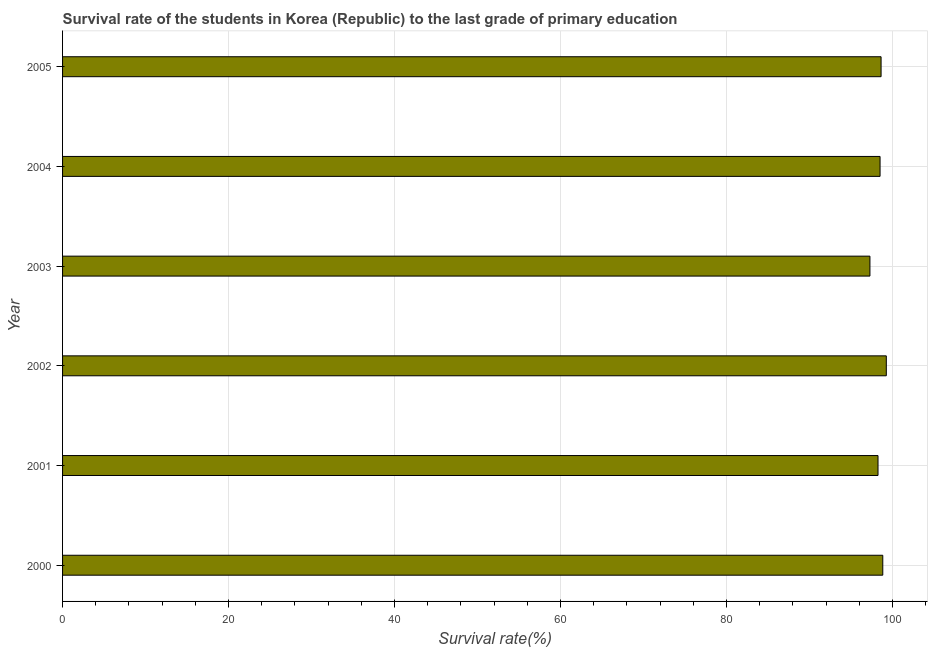What is the title of the graph?
Provide a succinct answer. Survival rate of the students in Korea (Republic) to the last grade of primary education. What is the label or title of the X-axis?
Ensure brevity in your answer.  Survival rate(%). What is the survival rate in primary education in 2002?
Ensure brevity in your answer.  99.24. Across all years, what is the maximum survival rate in primary education?
Make the answer very short. 99.24. Across all years, what is the minimum survival rate in primary education?
Provide a succinct answer. 97.27. What is the sum of the survival rate in primary education?
Provide a short and direct response. 590.69. What is the difference between the survival rate in primary education in 2000 and 2001?
Provide a short and direct response. 0.57. What is the average survival rate in primary education per year?
Provide a short and direct response. 98.45. What is the median survival rate in primary education?
Keep it short and to the point. 98.55. Do a majority of the years between 2004 and 2005 (inclusive) have survival rate in primary education greater than 48 %?
Keep it short and to the point. Yes. Is the difference between the survival rate in primary education in 2002 and 2003 greater than the difference between any two years?
Ensure brevity in your answer.  Yes. What is the difference between the highest and the second highest survival rate in primary education?
Your answer should be very brief. 0.42. Is the sum of the survival rate in primary education in 2000 and 2004 greater than the maximum survival rate in primary education across all years?
Provide a succinct answer. Yes. What is the difference between the highest and the lowest survival rate in primary education?
Keep it short and to the point. 1.97. Are all the bars in the graph horizontal?
Your answer should be compact. Yes. How many years are there in the graph?
Your answer should be compact. 6. Are the values on the major ticks of X-axis written in scientific E-notation?
Your response must be concise. No. What is the Survival rate(%) in 2000?
Ensure brevity in your answer.  98.82. What is the Survival rate(%) in 2001?
Offer a very short reply. 98.25. What is the Survival rate(%) in 2002?
Provide a succinct answer. 99.24. What is the Survival rate(%) of 2003?
Ensure brevity in your answer.  97.27. What is the Survival rate(%) of 2004?
Your response must be concise. 98.49. What is the Survival rate(%) in 2005?
Make the answer very short. 98.62. What is the difference between the Survival rate(%) in 2000 and 2001?
Offer a terse response. 0.57. What is the difference between the Survival rate(%) in 2000 and 2002?
Make the answer very short. -0.43. What is the difference between the Survival rate(%) in 2000 and 2003?
Your answer should be compact. 1.55. What is the difference between the Survival rate(%) in 2000 and 2004?
Your answer should be compact. 0.33. What is the difference between the Survival rate(%) in 2000 and 2005?
Ensure brevity in your answer.  0.2. What is the difference between the Survival rate(%) in 2001 and 2002?
Offer a very short reply. -1. What is the difference between the Survival rate(%) in 2001 and 2003?
Give a very brief answer. 0.97. What is the difference between the Survival rate(%) in 2001 and 2004?
Provide a short and direct response. -0.25. What is the difference between the Survival rate(%) in 2001 and 2005?
Your answer should be very brief. -0.37. What is the difference between the Survival rate(%) in 2002 and 2003?
Your response must be concise. 1.97. What is the difference between the Survival rate(%) in 2002 and 2004?
Provide a succinct answer. 0.75. What is the difference between the Survival rate(%) in 2002 and 2005?
Your response must be concise. 0.63. What is the difference between the Survival rate(%) in 2003 and 2004?
Offer a terse response. -1.22. What is the difference between the Survival rate(%) in 2003 and 2005?
Provide a succinct answer. -1.34. What is the difference between the Survival rate(%) in 2004 and 2005?
Your response must be concise. -0.12. What is the ratio of the Survival rate(%) in 2000 to that in 2001?
Keep it short and to the point. 1.01. What is the ratio of the Survival rate(%) in 2000 to that in 2002?
Ensure brevity in your answer.  1. What is the ratio of the Survival rate(%) in 2000 to that in 2004?
Offer a very short reply. 1. What is the ratio of the Survival rate(%) in 2000 to that in 2005?
Your answer should be very brief. 1. What is the ratio of the Survival rate(%) in 2001 to that in 2002?
Make the answer very short. 0.99. What is the ratio of the Survival rate(%) in 2001 to that in 2004?
Provide a succinct answer. 1. What is the ratio of the Survival rate(%) in 2002 to that in 2003?
Your answer should be compact. 1.02. What is the ratio of the Survival rate(%) in 2002 to that in 2005?
Your answer should be very brief. 1.01. What is the ratio of the Survival rate(%) in 2004 to that in 2005?
Offer a terse response. 1. 